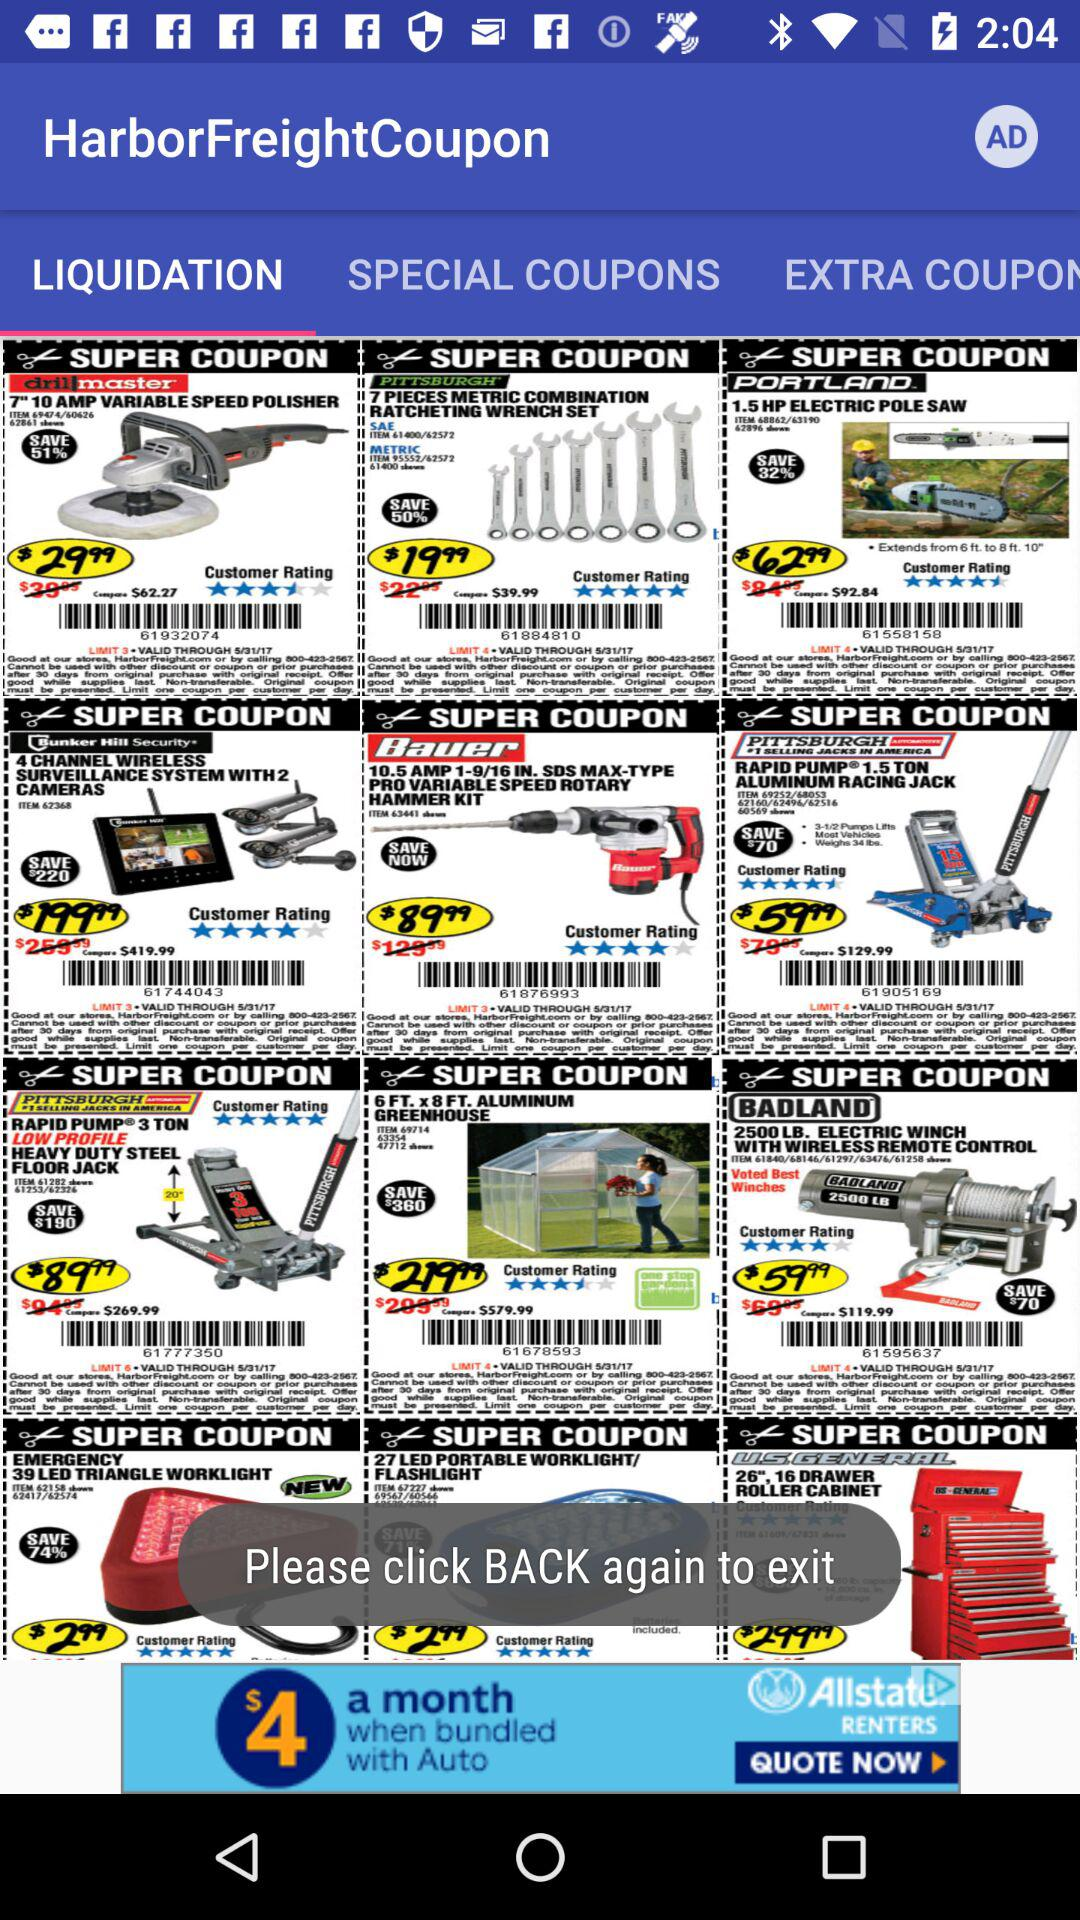How many special coupons are there?
When the provided information is insufficient, respond with <no answer>. <no answer> 